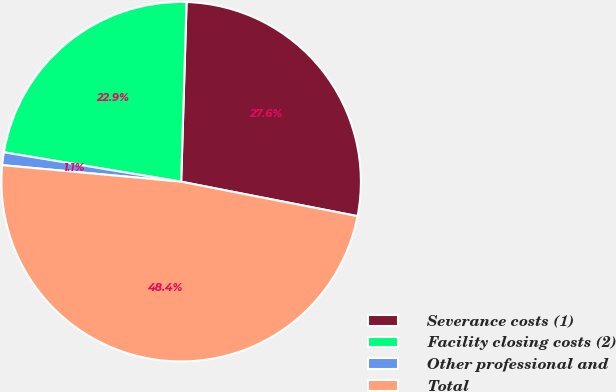Convert chart. <chart><loc_0><loc_0><loc_500><loc_500><pie_chart><fcel>Severance costs (1)<fcel>Facility closing costs (2)<fcel>Other professional and<fcel>Total<nl><fcel>27.59%<fcel>22.86%<fcel>1.15%<fcel>48.4%<nl></chart> 